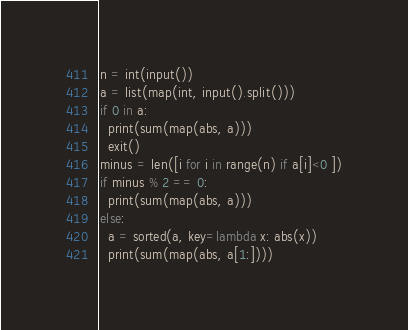Convert code to text. <code><loc_0><loc_0><loc_500><loc_500><_Python_>n = int(input())
a = list(map(int, input().split()))
if 0 in a:
  print(sum(map(abs, a)))
  exit()
minus = len([i for i in range(n) if a[i]<0 ])
if minus % 2 == 0:
  print(sum(map(abs, a)))
else:
  a = sorted(a, key=lambda x: abs(x))
  print(sum(map(abs, a[1:])))</code> 